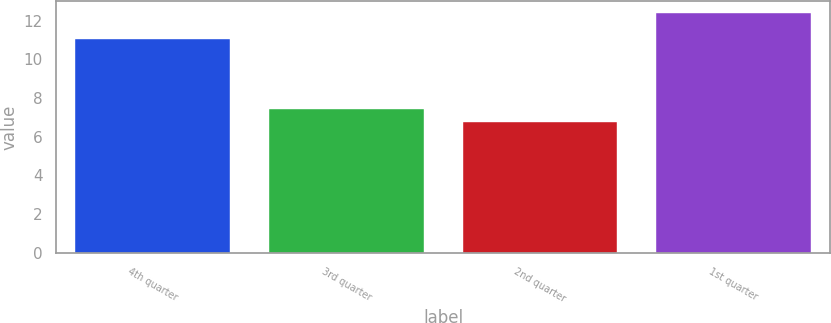<chart> <loc_0><loc_0><loc_500><loc_500><bar_chart><fcel>4th quarter<fcel>3rd quarter<fcel>2nd quarter<fcel>1st quarter<nl><fcel>11.06<fcel>7.43<fcel>6.76<fcel>12.4<nl></chart> 